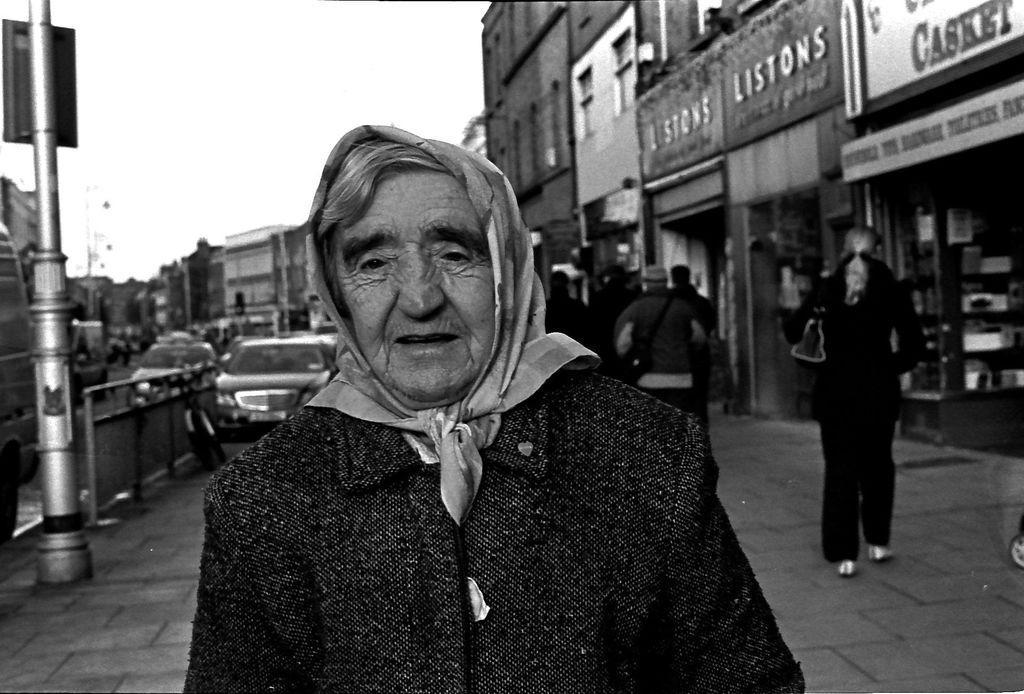Describe this image in one or two sentences. It looks like a black and white picture. We can see a person is standing on the walkway. Behind the person there is a group of people. On the left side of the person there is a pole with a board. Behind the people there is a bicycle and some vehicles on the road. Behind the vehicles there are buildings and the sky. 